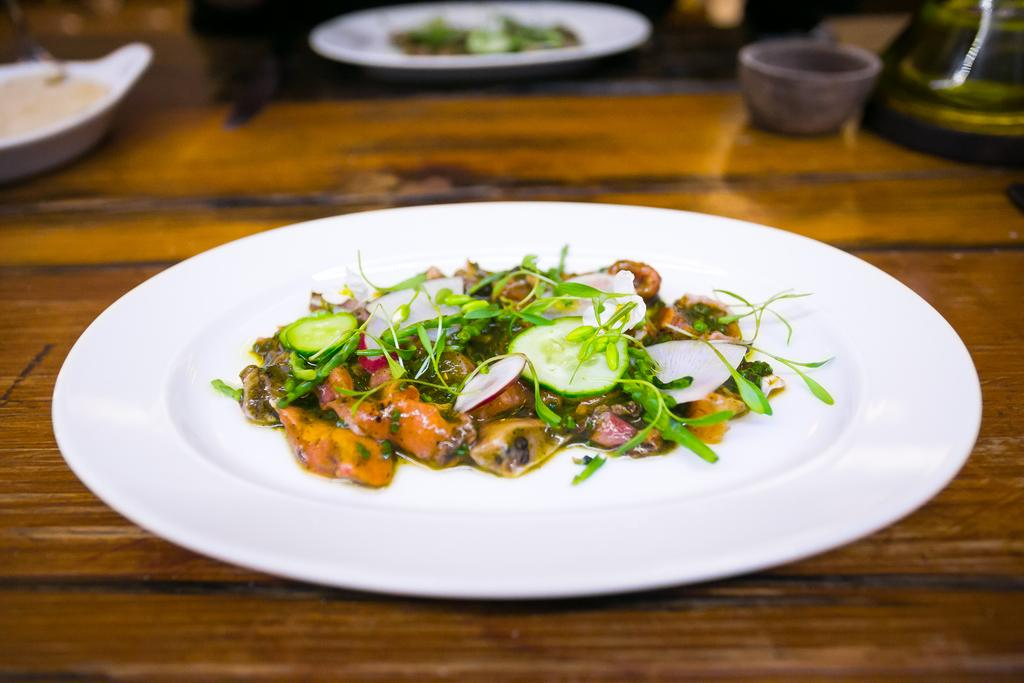What is the main dish in the image? There is a salad in a plate in the center of the image. Where is the plate with the salad located? The plate is placed on a table. What else can be seen on the table in the image? In the background, there is food visible, and there is a bowl placed on the table. What type of cream can be seen on the thrill ride in the image? There is no cream or thrill ride present in the image; it features a plate with a salad and a bowl on a table. How much dust can be seen on the salad in the image? There is no dust visible on the salad in the image; it appears clean and fresh. 